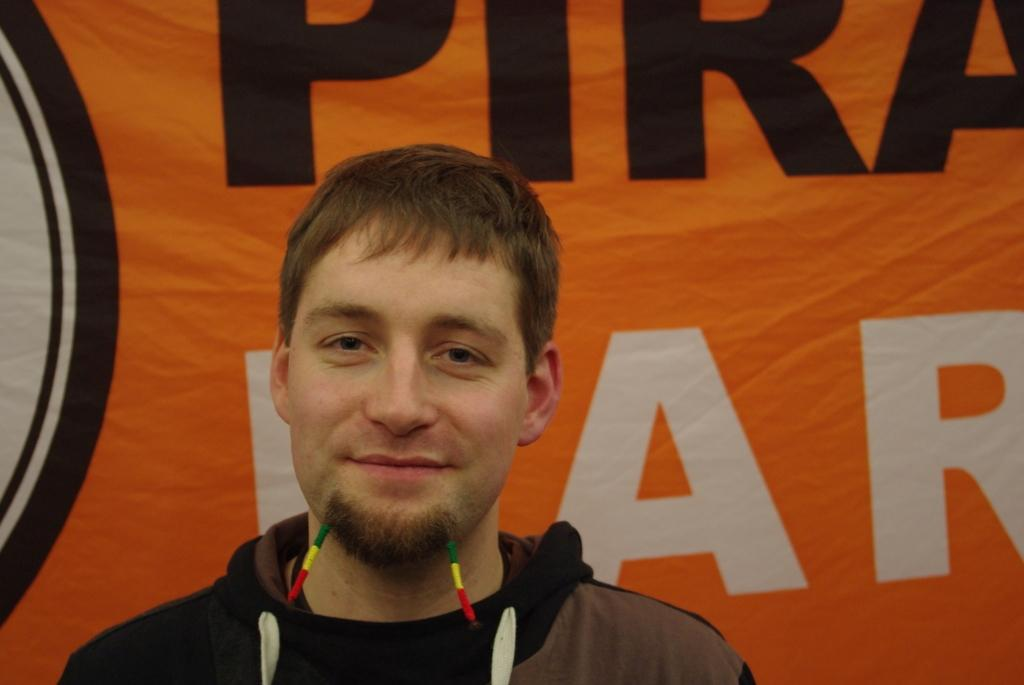Who or what is present in the image? There is a person in the image. What is the person wearing? The person is wearing a brown and black color dress. What can be seen in the background of the image? There is an orange color banner in the background of the image. What is written on the banner? There is text written on the banner. How many ladybugs can be seen crawling on the bed in the image? There is no bed or ladybugs present in the image. 